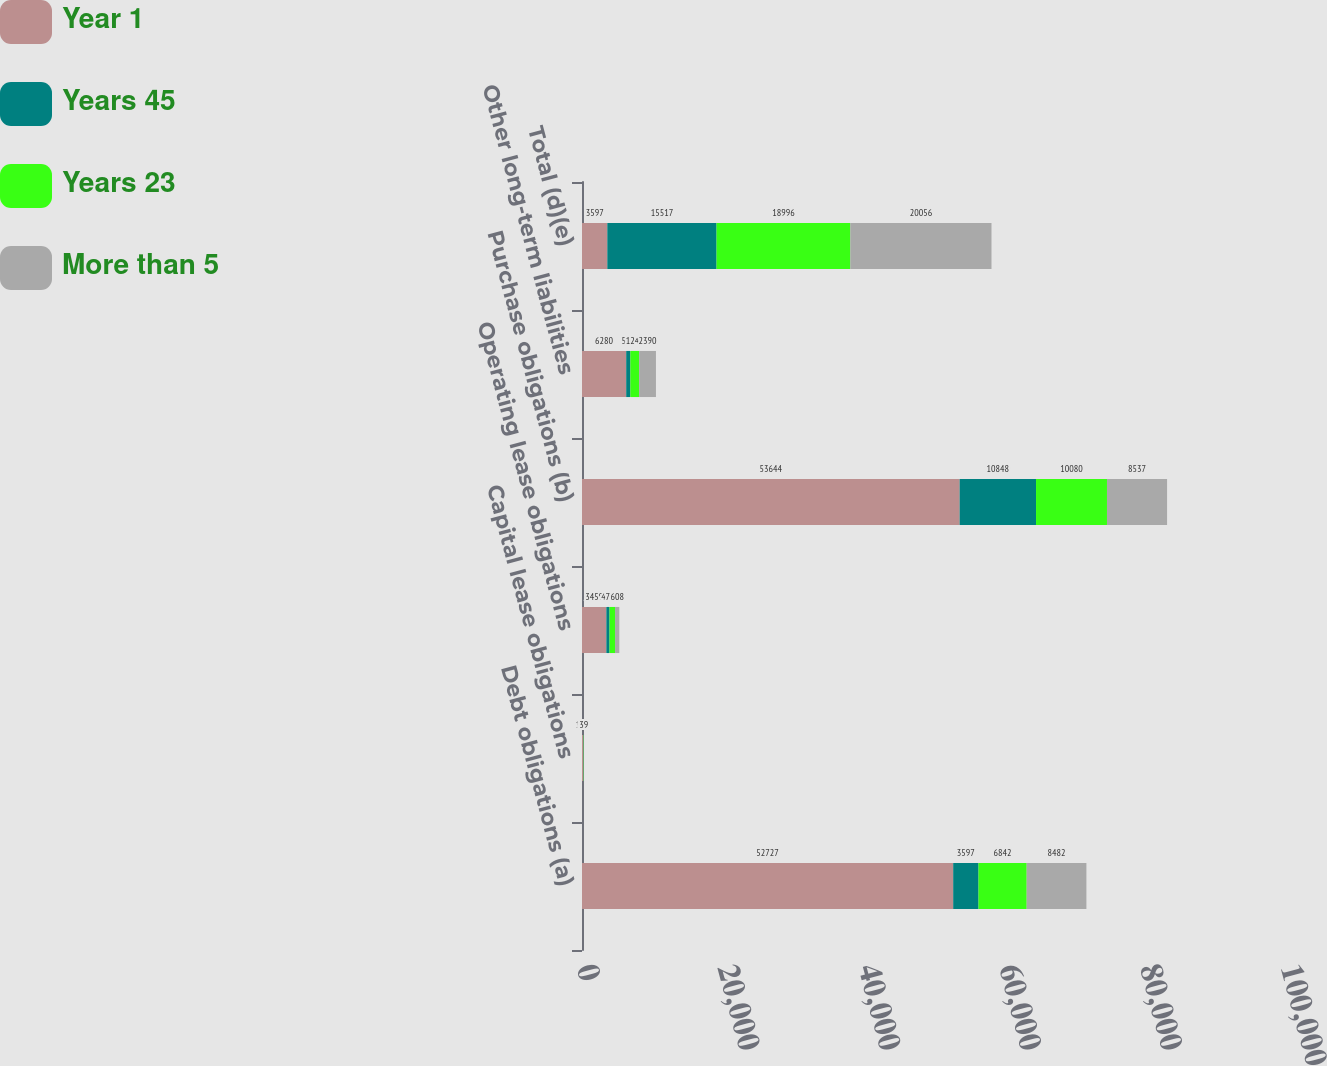Convert chart to OTSL. <chart><loc_0><loc_0><loc_500><loc_500><stacked_bar_chart><ecel><fcel>Debt obligations (a)<fcel>Capital lease obligations<fcel>Operating lease obligations<fcel>Purchase obligations (b)<fcel>Other long-term liabilities<fcel>Total (d)(e)<nl><fcel>Year 1<fcel>52727<fcel>156<fcel>3459<fcel>53644<fcel>6280<fcel>3597<nl><fcel>Years 45<fcel>3597<fcel>30<fcel>452<fcel>10848<fcel>590<fcel>15517<nl><fcel>Years 23<fcel>6842<fcel>47<fcel>782<fcel>10080<fcel>1245<fcel>18996<nl><fcel>More than 5<fcel>8482<fcel>39<fcel>608<fcel>8537<fcel>2390<fcel>20056<nl></chart> 